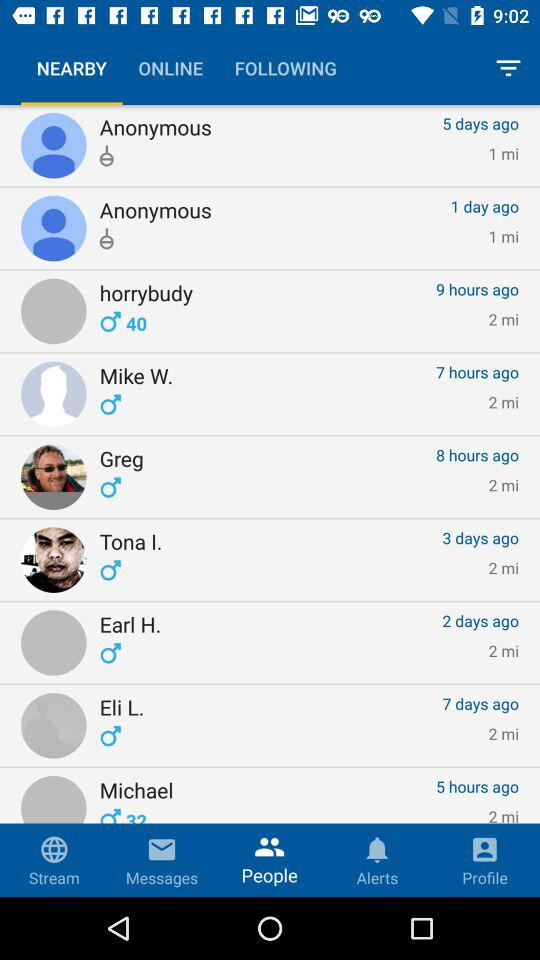Who was online five days ago? Five days ago, "Anonymous" was online. 